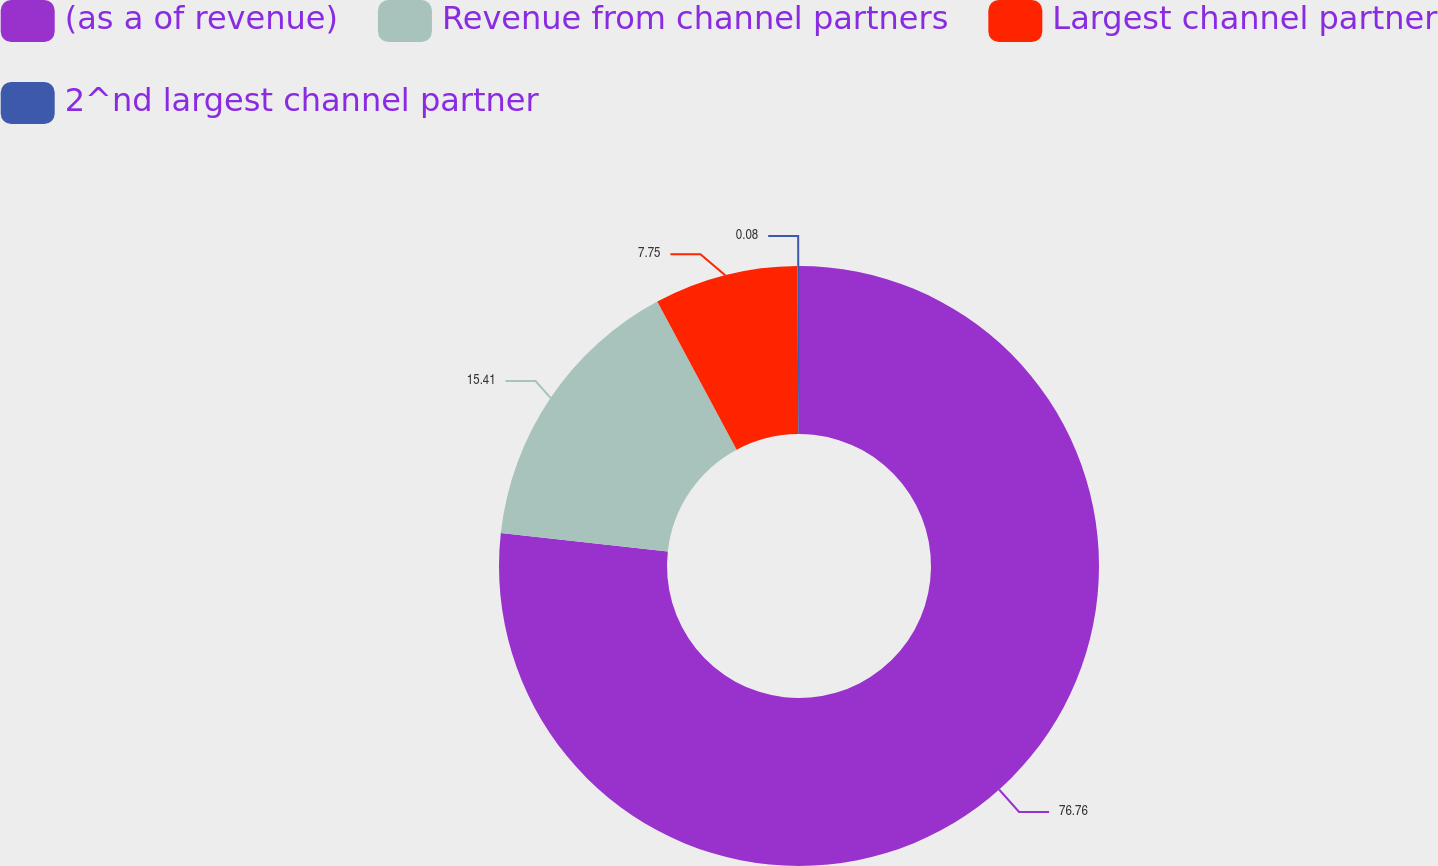Convert chart to OTSL. <chart><loc_0><loc_0><loc_500><loc_500><pie_chart><fcel>(as a of revenue)<fcel>Revenue from channel partners<fcel>Largest channel partner<fcel>2^nd largest channel partner<nl><fcel>76.76%<fcel>15.41%<fcel>7.75%<fcel>0.08%<nl></chart> 